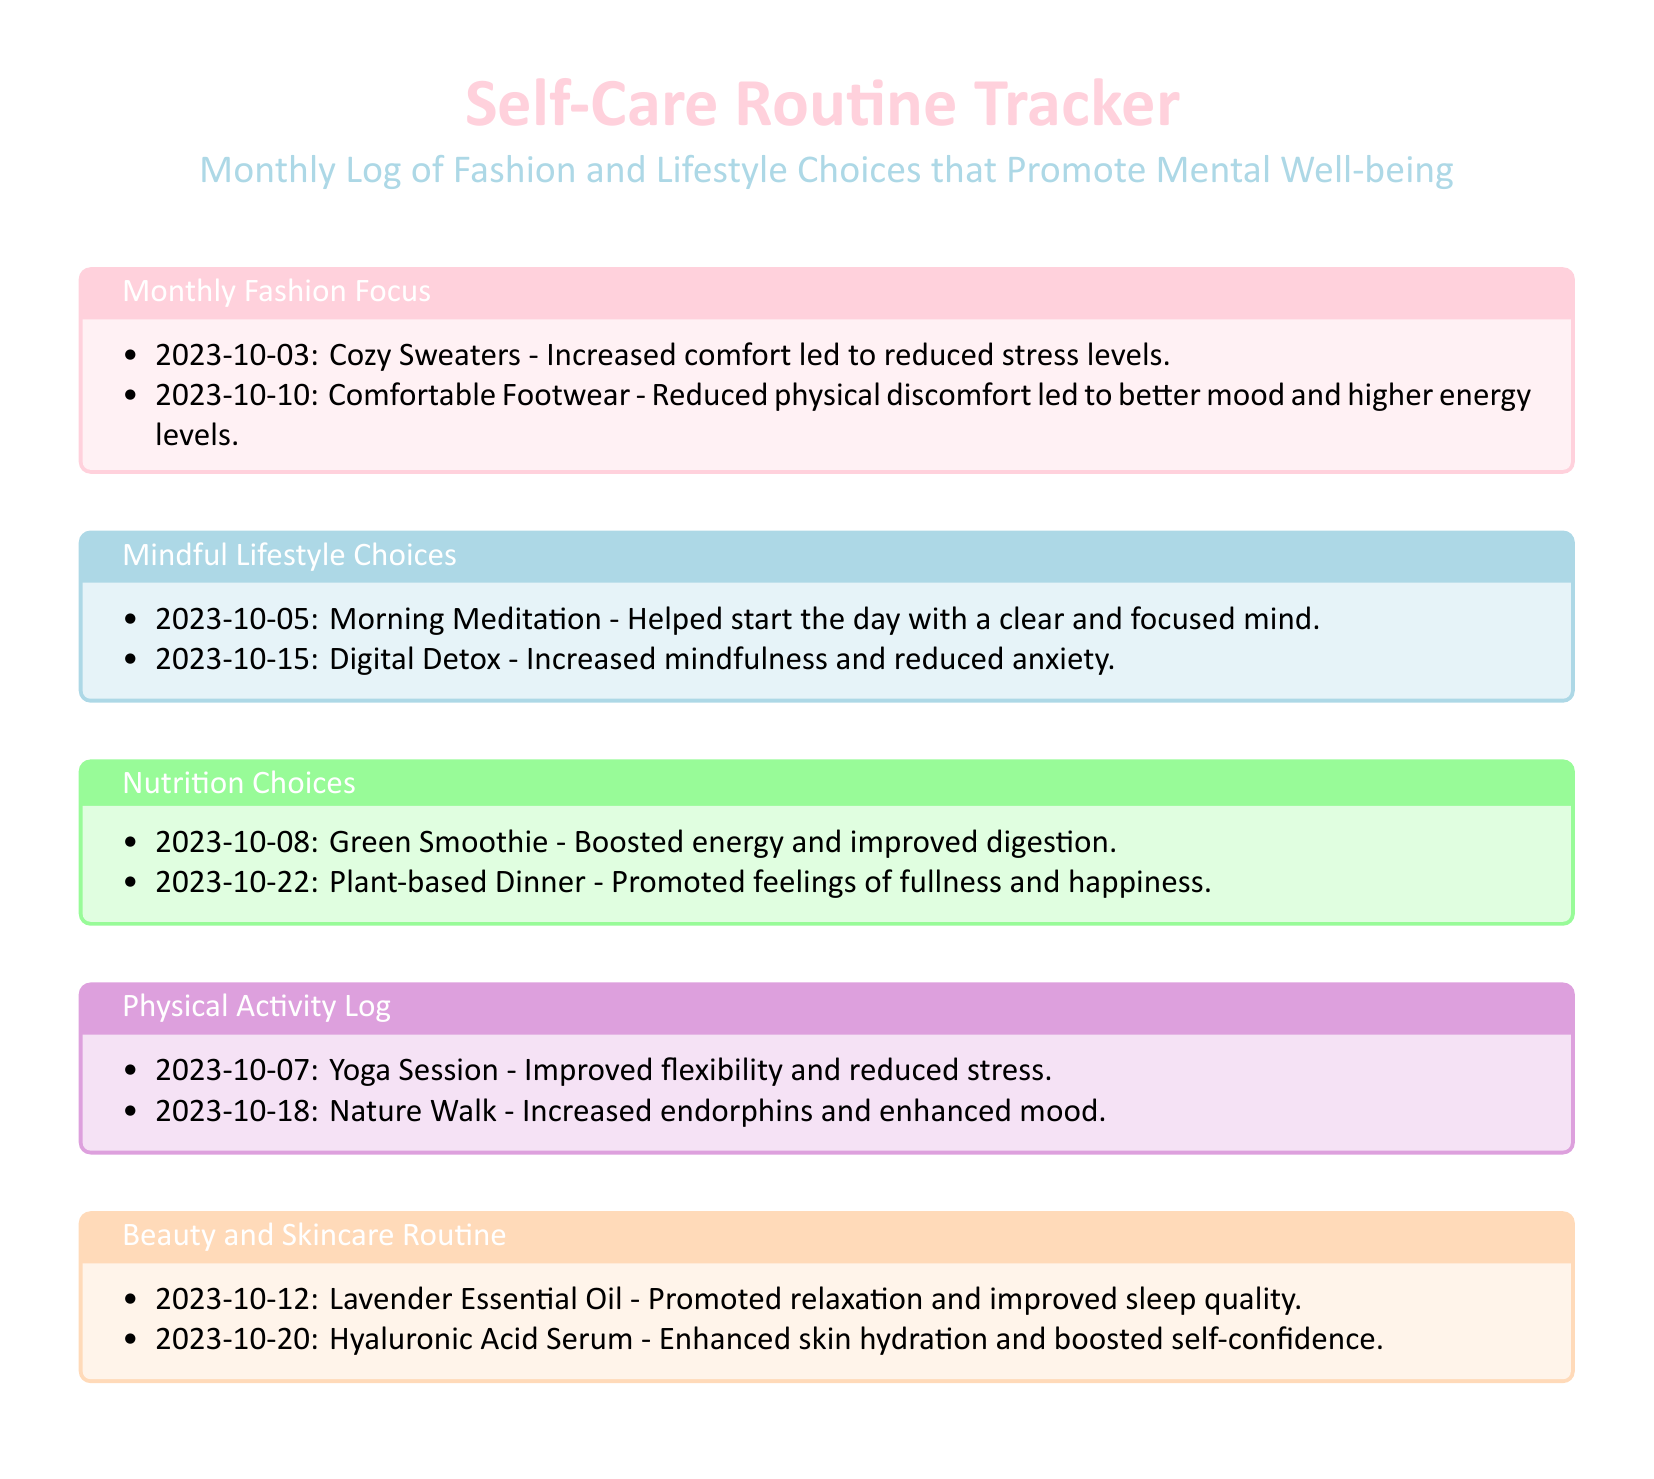what was the focus of the fashion on October 3rd? The entry for October 3rd states "Cozy Sweaters" as the fashion focus.
Answer: Cozy Sweaters what lifestyle choice was made on October 5th? The document lists "Morning Meditation" as a mindful lifestyle choice made on this date.
Answer: Morning Meditation how did comfortable footwear impact mood? The entry for comfortable footwear mentions that it "reduced physical discomfort led to better mood."
Answer: Better mood what nutrition choice was made on October 8th? The nutrition choice listed for October 8th is "Green Smoothie."
Answer: Green Smoothie what was the benefit of the yoga session on October 7th? The document states that the yoga session "improved flexibility and reduced stress."
Answer: Improved flexibility how many mindful lifestyle choices are noted in the document? There are a total of two entries under the "Mindful Lifestyle Choices" section.
Answer: Two which beauty product was used on October 12th? The beauty product noted for use on October 12th is "Lavender Essential Oil."
Answer: Lavender Essential Oil what physical activity took place on October 18th? The physical activity logged for October 18th is "Nature Walk."
Answer: Nature Walk which color represents the section for Nutrition Choices? The section for Nutrition Choices is represented in pastel green color.
Answer: Pastel Green 